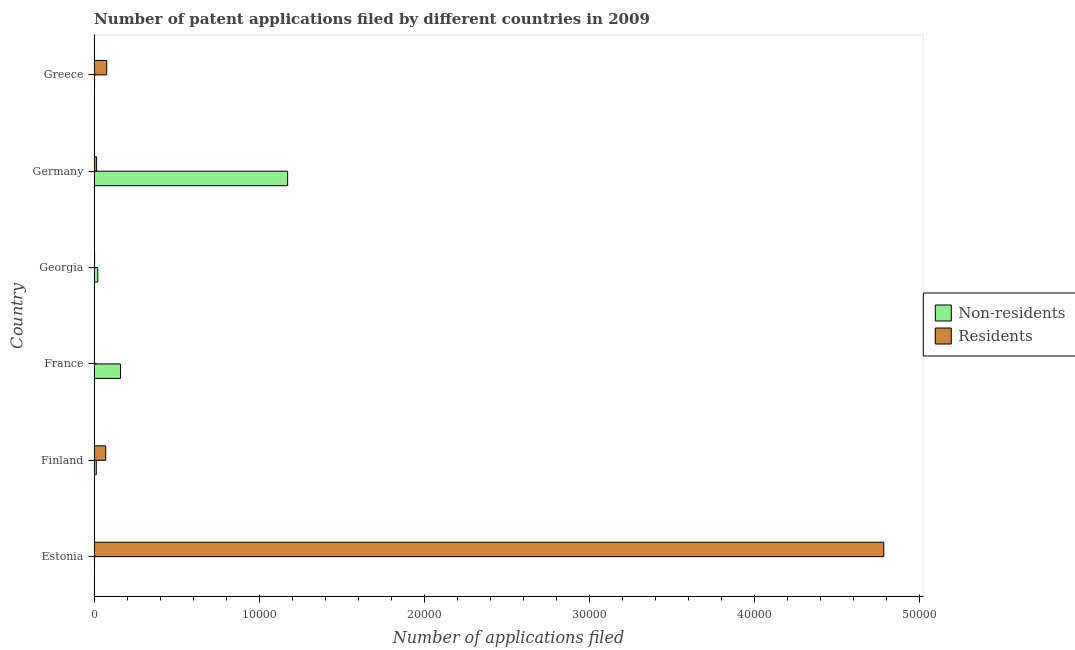How many groups of bars are there?
Give a very brief answer. 6. Are the number of bars per tick equal to the number of legend labels?
Ensure brevity in your answer.  Yes. How many bars are there on the 6th tick from the top?
Give a very brief answer. 2. What is the label of the 6th group of bars from the top?
Give a very brief answer. Estonia. What is the number of patent applications by non residents in France?
Your response must be concise. 1593. Across all countries, what is the maximum number of patent applications by residents?
Make the answer very short. 4.79e+04. Across all countries, what is the minimum number of patent applications by residents?
Give a very brief answer. 7. In which country was the number of patent applications by residents maximum?
Your answer should be compact. Estonia. What is the total number of patent applications by residents in the graph?
Offer a terse response. 4.95e+04. What is the difference between the number of patent applications by non residents in Georgia and that in Germany?
Offer a terse response. -1.15e+04. What is the difference between the number of patent applications by residents in Finland and the number of patent applications by non residents in France?
Ensure brevity in your answer.  -895. What is the average number of patent applications by non residents per country?
Offer a very short reply. 2284. What is the difference between the number of patent applications by non residents and number of patent applications by residents in Greece?
Make the answer very short. -735. In how many countries, is the number of patent applications by non residents greater than 36000 ?
Your response must be concise. 0. What is the ratio of the number of patent applications by residents in Estonia to that in Georgia?
Your answer should be very brief. 1994.12. What is the difference between the highest and the second highest number of patent applications by non residents?
Your answer should be compact. 1.01e+04. What is the difference between the highest and the lowest number of patent applications by residents?
Provide a short and direct response. 4.79e+04. Is the sum of the number of patent applications by non residents in Estonia and France greater than the maximum number of patent applications by residents across all countries?
Your answer should be compact. No. What does the 1st bar from the top in Finland represents?
Your answer should be very brief. Residents. What does the 2nd bar from the bottom in France represents?
Keep it short and to the point. Residents. Are all the bars in the graph horizontal?
Your response must be concise. Yes. How many countries are there in the graph?
Ensure brevity in your answer.  6. What is the difference between two consecutive major ticks on the X-axis?
Your answer should be very brief. 10000. How are the legend labels stacked?
Your answer should be very brief. Vertical. What is the title of the graph?
Ensure brevity in your answer.  Number of patent applications filed by different countries in 2009. What is the label or title of the X-axis?
Make the answer very short. Number of applications filed. What is the label or title of the Y-axis?
Ensure brevity in your answer.  Country. What is the Number of applications filed in Non-residents in Estonia?
Your answer should be very brief. 20. What is the Number of applications filed of Residents in Estonia?
Offer a terse response. 4.79e+04. What is the Number of applications filed of Non-residents in Finland?
Your answer should be compact. 127. What is the Number of applications filed of Residents in Finland?
Provide a short and direct response. 698. What is the Number of applications filed in Non-residents in France?
Offer a very short reply. 1593. What is the Number of applications filed in Non-residents in Georgia?
Your answer should be compact. 218. What is the Number of applications filed in Residents in Georgia?
Offer a terse response. 24. What is the Number of applications filed of Non-residents in Germany?
Your answer should be very brief. 1.17e+04. What is the Number of applications filed in Residents in Germany?
Provide a short and direct response. 149. What is the Number of applications filed of Non-residents in Greece?
Offer a terse response. 22. What is the Number of applications filed in Residents in Greece?
Your answer should be compact. 757. Across all countries, what is the maximum Number of applications filed in Non-residents?
Your answer should be very brief. 1.17e+04. Across all countries, what is the maximum Number of applications filed of Residents?
Your answer should be compact. 4.79e+04. Across all countries, what is the minimum Number of applications filed of Non-residents?
Offer a terse response. 20. Across all countries, what is the minimum Number of applications filed of Residents?
Your response must be concise. 7. What is the total Number of applications filed in Non-residents in the graph?
Give a very brief answer. 1.37e+04. What is the total Number of applications filed of Residents in the graph?
Offer a very short reply. 4.95e+04. What is the difference between the Number of applications filed of Non-residents in Estonia and that in Finland?
Your answer should be very brief. -107. What is the difference between the Number of applications filed of Residents in Estonia and that in Finland?
Provide a succinct answer. 4.72e+04. What is the difference between the Number of applications filed of Non-residents in Estonia and that in France?
Offer a terse response. -1573. What is the difference between the Number of applications filed of Residents in Estonia and that in France?
Give a very brief answer. 4.79e+04. What is the difference between the Number of applications filed of Non-residents in Estonia and that in Georgia?
Your answer should be compact. -198. What is the difference between the Number of applications filed in Residents in Estonia and that in Georgia?
Ensure brevity in your answer.  4.78e+04. What is the difference between the Number of applications filed of Non-residents in Estonia and that in Germany?
Provide a succinct answer. -1.17e+04. What is the difference between the Number of applications filed in Residents in Estonia and that in Germany?
Your response must be concise. 4.77e+04. What is the difference between the Number of applications filed of Non-residents in Estonia and that in Greece?
Make the answer very short. -2. What is the difference between the Number of applications filed of Residents in Estonia and that in Greece?
Your answer should be compact. 4.71e+04. What is the difference between the Number of applications filed of Non-residents in Finland and that in France?
Provide a short and direct response. -1466. What is the difference between the Number of applications filed of Residents in Finland and that in France?
Keep it short and to the point. 691. What is the difference between the Number of applications filed in Non-residents in Finland and that in Georgia?
Your answer should be very brief. -91. What is the difference between the Number of applications filed in Residents in Finland and that in Georgia?
Provide a succinct answer. 674. What is the difference between the Number of applications filed in Non-residents in Finland and that in Germany?
Provide a succinct answer. -1.16e+04. What is the difference between the Number of applications filed of Residents in Finland and that in Germany?
Give a very brief answer. 549. What is the difference between the Number of applications filed in Non-residents in Finland and that in Greece?
Offer a very short reply. 105. What is the difference between the Number of applications filed in Residents in Finland and that in Greece?
Make the answer very short. -59. What is the difference between the Number of applications filed in Non-residents in France and that in Georgia?
Make the answer very short. 1375. What is the difference between the Number of applications filed of Non-residents in France and that in Germany?
Provide a succinct answer. -1.01e+04. What is the difference between the Number of applications filed in Residents in France and that in Germany?
Offer a terse response. -142. What is the difference between the Number of applications filed of Non-residents in France and that in Greece?
Provide a succinct answer. 1571. What is the difference between the Number of applications filed of Residents in France and that in Greece?
Make the answer very short. -750. What is the difference between the Number of applications filed of Non-residents in Georgia and that in Germany?
Ensure brevity in your answer.  -1.15e+04. What is the difference between the Number of applications filed in Residents in Georgia and that in Germany?
Offer a very short reply. -125. What is the difference between the Number of applications filed in Non-residents in Georgia and that in Greece?
Offer a very short reply. 196. What is the difference between the Number of applications filed of Residents in Georgia and that in Greece?
Your answer should be very brief. -733. What is the difference between the Number of applications filed of Non-residents in Germany and that in Greece?
Make the answer very short. 1.17e+04. What is the difference between the Number of applications filed in Residents in Germany and that in Greece?
Provide a short and direct response. -608. What is the difference between the Number of applications filed of Non-residents in Estonia and the Number of applications filed of Residents in Finland?
Your response must be concise. -678. What is the difference between the Number of applications filed of Non-residents in Estonia and the Number of applications filed of Residents in France?
Provide a short and direct response. 13. What is the difference between the Number of applications filed in Non-residents in Estonia and the Number of applications filed in Residents in Germany?
Make the answer very short. -129. What is the difference between the Number of applications filed in Non-residents in Estonia and the Number of applications filed in Residents in Greece?
Your response must be concise. -737. What is the difference between the Number of applications filed of Non-residents in Finland and the Number of applications filed of Residents in France?
Make the answer very short. 120. What is the difference between the Number of applications filed of Non-residents in Finland and the Number of applications filed of Residents in Georgia?
Make the answer very short. 103. What is the difference between the Number of applications filed of Non-residents in Finland and the Number of applications filed of Residents in Germany?
Your response must be concise. -22. What is the difference between the Number of applications filed of Non-residents in Finland and the Number of applications filed of Residents in Greece?
Keep it short and to the point. -630. What is the difference between the Number of applications filed in Non-residents in France and the Number of applications filed in Residents in Georgia?
Give a very brief answer. 1569. What is the difference between the Number of applications filed in Non-residents in France and the Number of applications filed in Residents in Germany?
Your response must be concise. 1444. What is the difference between the Number of applications filed in Non-residents in France and the Number of applications filed in Residents in Greece?
Offer a very short reply. 836. What is the difference between the Number of applications filed in Non-residents in Georgia and the Number of applications filed in Residents in Germany?
Offer a very short reply. 69. What is the difference between the Number of applications filed of Non-residents in Georgia and the Number of applications filed of Residents in Greece?
Offer a terse response. -539. What is the difference between the Number of applications filed of Non-residents in Germany and the Number of applications filed of Residents in Greece?
Give a very brief answer. 1.10e+04. What is the average Number of applications filed of Non-residents per country?
Make the answer very short. 2284. What is the average Number of applications filed in Residents per country?
Your answer should be compact. 8249. What is the difference between the Number of applications filed of Non-residents and Number of applications filed of Residents in Estonia?
Make the answer very short. -4.78e+04. What is the difference between the Number of applications filed in Non-residents and Number of applications filed in Residents in Finland?
Your answer should be compact. -571. What is the difference between the Number of applications filed in Non-residents and Number of applications filed in Residents in France?
Provide a succinct answer. 1586. What is the difference between the Number of applications filed in Non-residents and Number of applications filed in Residents in Georgia?
Make the answer very short. 194. What is the difference between the Number of applications filed in Non-residents and Number of applications filed in Residents in Germany?
Your response must be concise. 1.16e+04. What is the difference between the Number of applications filed of Non-residents and Number of applications filed of Residents in Greece?
Ensure brevity in your answer.  -735. What is the ratio of the Number of applications filed in Non-residents in Estonia to that in Finland?
Your answer should be compact. 0.16. What is the ratio of the Number of applications filed in Residents in Estonia to that in Finland?
Ensure brevity in your answer.  68.57. What is the ratio of the Number of applications filed of Non-residents in Estonia to that in France?
Provide a succinct answer. 0.01. What is the ratio of the Number of applications filed of Residents in Estonia to that in France?
Ensure brevity in your answer.  6837. What is the ratio of the Number of applications filed in Non-residents in Estonia to that in Georgia?
Your answer should be very brief. 0.09. What is the ratio of the Number of applications filed in Residents in Estonia to that in Georgia?
Your answer should be compact. 1994.12. What is the ratio of the Number of applications filed in Non-residents in Estonia to that in Germany?
Your response must be concise. 0. What is the ratio of the Number of applications filed in Residents in Estonia to that in Germany?
Offer a very short reply. 321.2. What is the ratio of the Number of applications filed of Non-residents in Estonia to that in Greece?
Provide a succinct answer. 0.91. What is the ratio of the Number of applications filed in Residents in Estonia to that in Greece?
Your answer should be compact. 63.22. What is the ratio of the Number of applications filed of Non-residents in Finland to that in France?
Provide a succinct answer. 0.08. What is the ratio of the Number of applications filed of Residents in Finland to that in France?
Provide a short and direct response. 99.71. What is the ratio of the Number of applications filed of Non-residents in Finland to that in Georgia?
Your response must be concise. 0.58. What is the ratio of the Number of applications filed in Residents in Finland to that in Georgia?
Make the answer very short. 29.08. What is the ratio of the Number of applications filed in Non-residents in Finland to that in Germany?
Give a very brief answer. 0.01. What is the ratio of the Number of applications filed of Residents in Finland to that in Germany?
Provide a short and direct response. 4.68. What is the ratio of the Number of applications filed in Non-residents in Finland to that in Greece?
Give a very brief answer. 5.77. What is the ratio of the Number of applications filed of Residents in Finland to that in Greece?
Give a very brief answer. 0.92. What is the ratio of the Number of applications filed of Non-residents in France to that in Georgia?
Offer a terse response. 7.31. What is the ratio of the Number of applications filed of Residents in France to that in Georgia?
Offer a very short reply. 0.29. What is the ratio of the Number of applications filed of Non-residents in France to that in Germany?
Provide a short and direct response. 0.14. What is the ratio of the Number of applications filed of Residents in France to that in Germany?
Provide a succinct answer. 0.05. What is the ratio of the Number of applications filed of Non-residents in France to that in Greece?
Ensure brevity in your answer.  72.41. What is the ratio of the Number of applications filed of Residents in France to that in Greece?
Ensure brevity in your answer.  0.01. What is the ratio of the Number of applications filed of Non-residents in Georgia to that in Germany?
Provide a short and direct response. 0.02. What is the ratio of the Number of applications filed of Residents in Georgia to that in Germany?
Offer a terse response. 0.16. What is the ratio of the Number of applications filed in Non-residents in Georgia to that in Greece?
Offer a terse response. 9.91. What is the ratio of the Number of applications filed of Residents in Georgia to that in Greece?
Make the answer very short. 0.03. What is the ratio of the Number of applications filed of Non-residents in Germany to that in Greece?
Provide a short and direct response. 532.91. What is the ratio of the Number of applications filed in Residents in Germany to that in Greece?
Your response must be concise. 0.2. What is the difference between the highest and the second highest Number of applications filed of Non-residents?
Make the answer very short. 1.01e+04. What is the difference between the highest and the second highest Number of applications filed in Residents?
Your answer should be very brief. 4.71e+04. What is the difference between the highest and the lowest Number of applications filed of Non-residents?
Offer a very short reply. 1.17e+04. What is the difference between the highest and the lowest Number of applications filed of Residents?
Provide a short and direct response. 4.79e+04. 